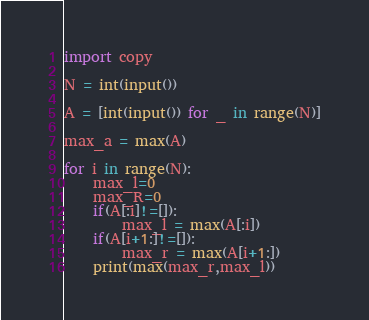Convert code to text. <code><loc_0><loc_0><loc_500><loc_500><_Python_>import copy

N = int(input())

A = [int(input()) for _ in range(N)]

max_a = max(A)

for i in range(N):
    max_l=0
    max_R=0
    if(A[:i]!=[]):
        max_l = max(A[:i])
    if(A[i+1:]!=[]):
        max_r = max(A[i+1:])
    print(max(max_r,max_l))
</code> 